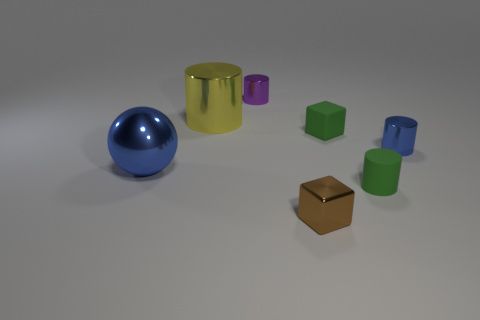There is a blue object left of the small shiny cylinder that is on the left side of the green cube; what is its shape? The blue object positioned to the left of the small, shiny cylinder—which itself lies on the left side of the green cube—is a sphere. Given the smooth and unbroken reflection visible on its surface, we can identify its shape as perfectly round, which is characteristic of a sphere. 